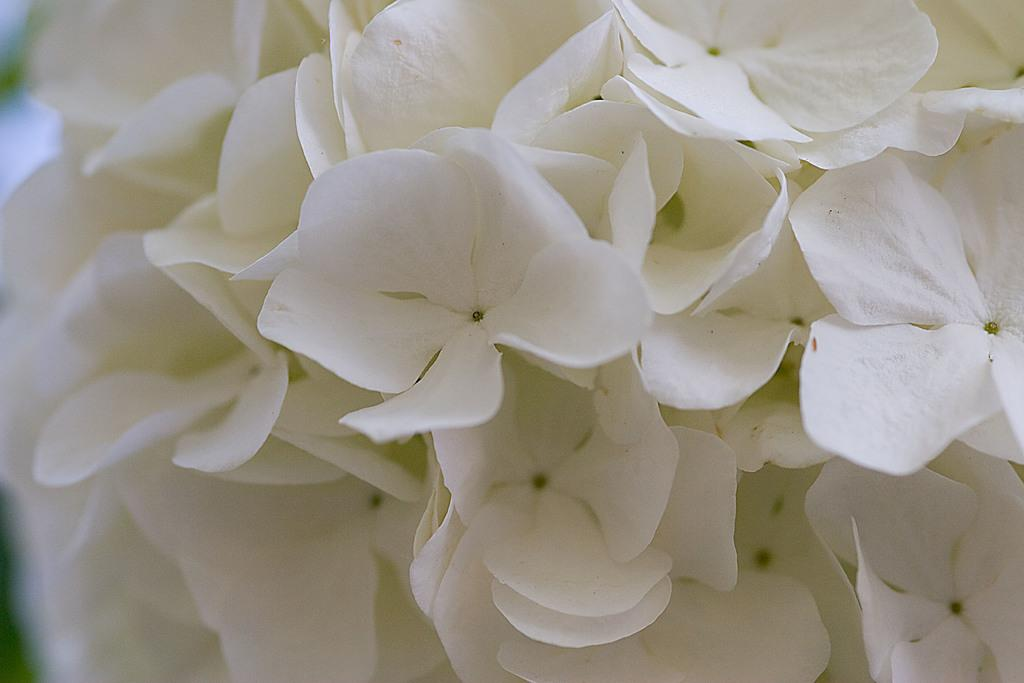What type of flowers can be seen in the image? There are white colored flowers in the image. What type of rifle is being used to shoot the trains in the image? There is no rifle or trains present in the image; it features white colored flowers. How many clocks can be seen in the image? There are no clocks present in the image; it features white colored flowers. 